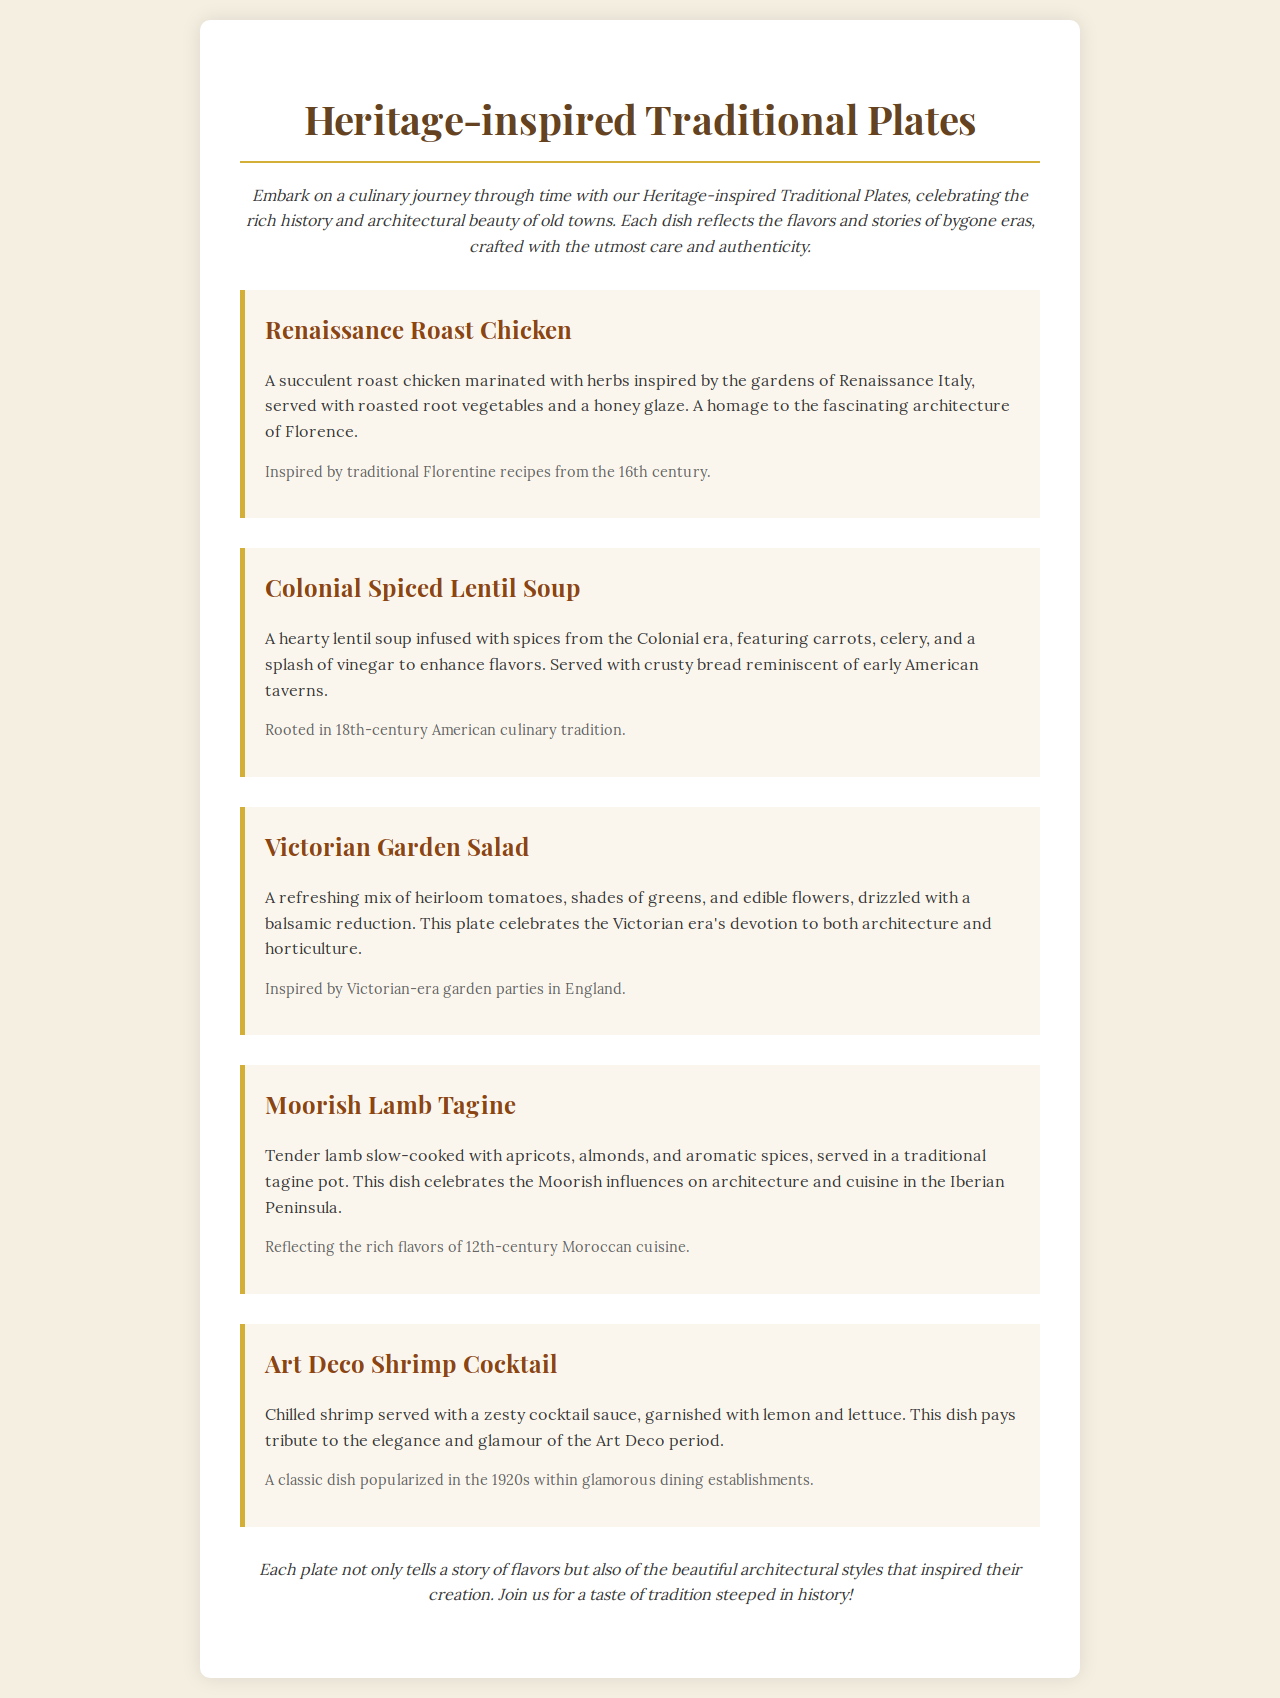What is the first dish listed on the menu? The first dish mentioned in the document is "Renaissance Roast Chicken."
Answer: Renaissance Roast Chicken Which dish is inspired by Colonial-era recipes? The dish that is inspired by Colonial-era recipes is "Colonial Spiced Lentil Soup."
Answer: Colonial Spiced Lentil Soup How many dishes are featured in the menu? There are a total of five dishes featured in the menu.
Answer: Five What type of cuisine does Moorish Lamb Tagine represent? Moorish Lamb Tagine represents 12th-century Moroccan cuisine.
Answer: 12th-century Moroccan What is the origin of the Victorian Garden Salad? The origin of the Victorian Garden Salad is related to garden parties in England during the Victorian era.
Answer: Victorian-era garden parties in England Name one ingredient in the Colonial Spiced Lentil Soup. One ingredient in the Colonial Spiced Lentil Soup is lentils.
Answer: Lentils What is a key characteristic of Art Deco Shrimp Cocktail? A key characteristic of Art Deco Shrimp Cocktail is its elegance and glamour from the 1920s.
Answer: Elegance and glamour What type of sauce is served with the Art Deco Shrimp Cocktail? The sauce served with the Art Deco Shrimp Cocktail is a zesty cocktail sauce.
Answer: Zesty cocktail sauce Which dish reflects the flavors and architecture of Florence? The dish that reflects the flavors and architecture of Florence is "Renaissance Roast Chicken."
Answer: Renaissance Roast Chicken 